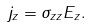<formula> <loc_0><loc_0><loc_500><loc_500>j _ { z } = \sigma _ { z z } E _ { z } .</formula> 